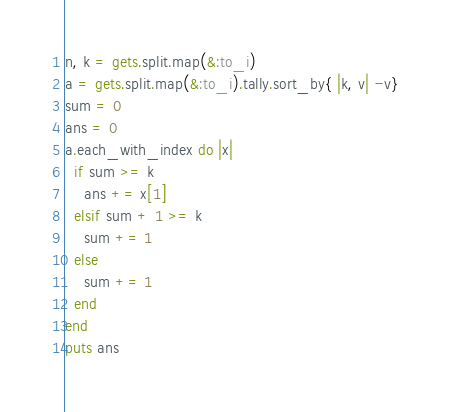Convert code to text. <code><loc_0><loc_0><loc_500><loc_500><_Ruby_>n, k = gets.split.map(&:to_i)
a = gets.split.map(&:to_i).tally.sort_by{ |k, v| -v}
sum = 0
ans = 0
a.each_with_index do |x|
  if sum >= k
    ans += x[1]
  elsif sum + 1 >= k
    sum += 1
  else
    sum += 1
  end
end
puts ans
</code> 